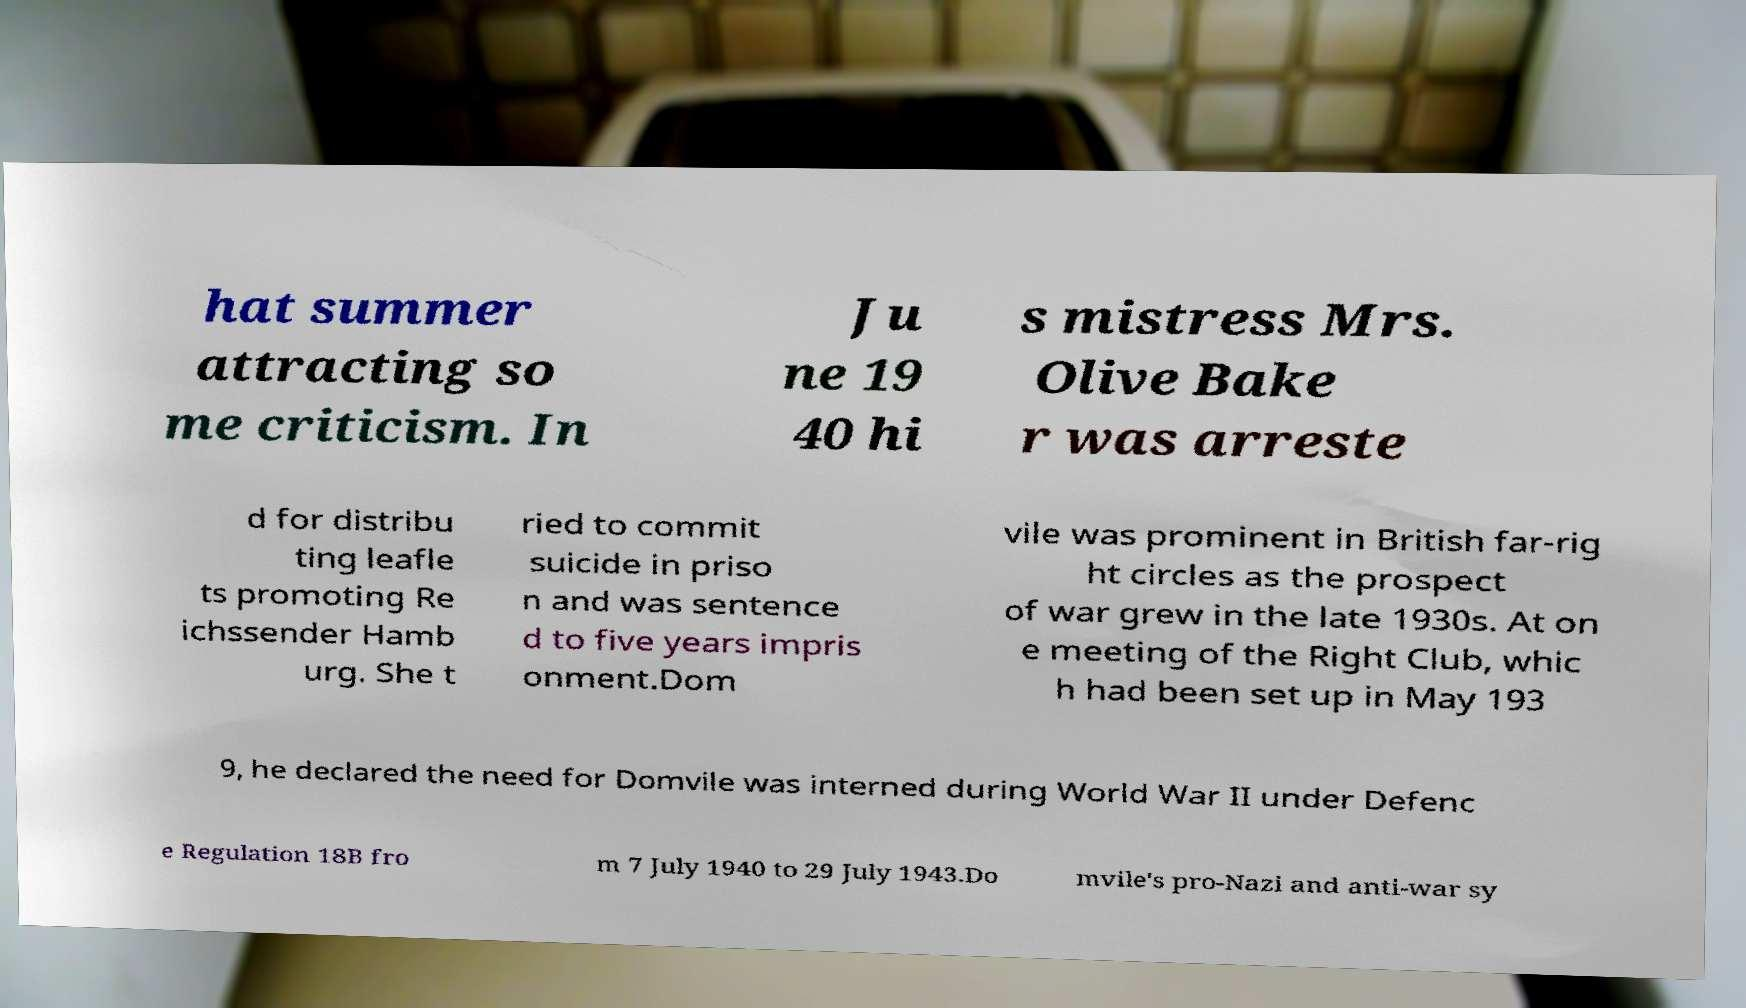There's text embedded in this image that I need extracted. Can you transcribe it verbatim? hat summer attracting so me criticism. In Ju ne 19 40 hi s mistress Mrs. Olive Bake r was arreste d for distribu ting leafle ts promoting Re ichssender Hamb urg. She t ried to commit suicide in priso n and was sentence d to five years impris onment.Dom vile was prominent in British far-rig ht circles as the prospect of war grew in the late 1930s. At on e meeting of the Right Club, whic h had been set up in May 193 9, he declared the need for Domvile was interned during World War II under Defenc e Regulation 18B fro m 7 July 1940 to 29 July 1943.Do mvile's pro-Nazi and anti-war sy 